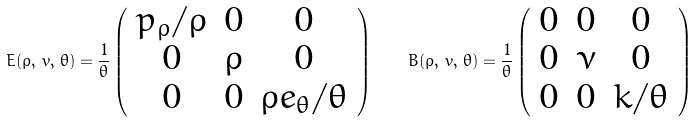Convert formula to latex. <formula><loc_0><loc_0><loc_500><loc_500>E ( \rho , \, v , \, \theta ) = \frac { 1 } { \theta } \left ( \begin{array} { c c c } p _ { \rho } / \rho & 0 & 0 \\ 0 & \rho & 0 \\ 0 & 0 & \rho e _ { \theta } / \theta \\ \end{array} \right ) \quad B ( \rho , \, v , \, \theta ) = \frac { 1 } { \theta } \left ( \begin{array} { c c c } 0 & 0 & 0 \\ 0 & \nu & 0 \\ 0 & 0 & k / \theta \\ \end{array} \right )</formula> 